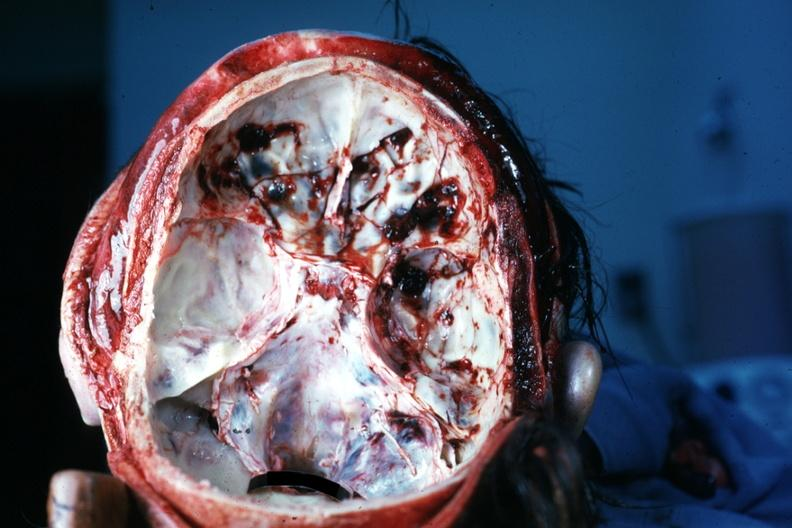what does this image show?
Answer the question using a single word or phrase. Multiple fractures very good 